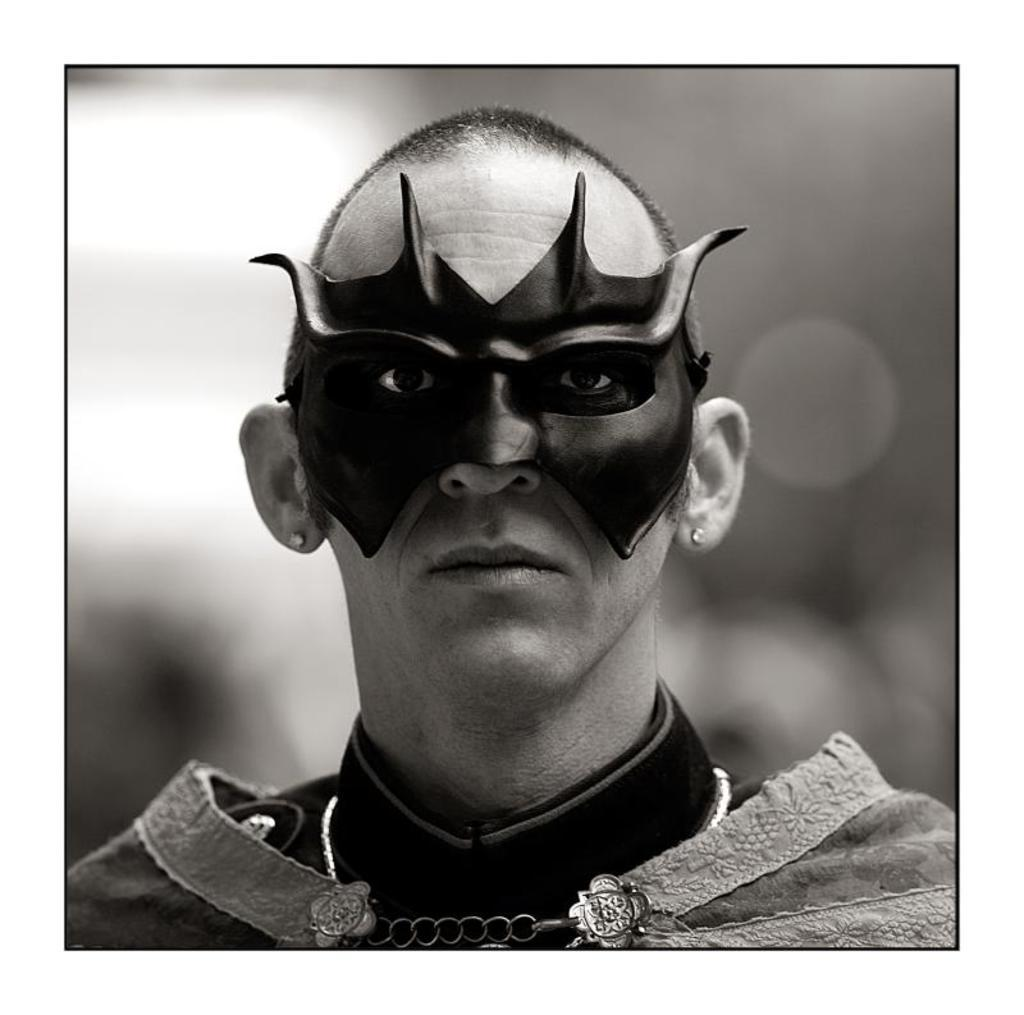What is the color scheme of the image? The image is black and white. How would you describe the background of the image? The background of the image is blurred. What is the main subject of the image? There is a man in the middle of the image. What is the man wearing in the image? The man is wearing a costume. Can you describe the man's face in the image? There is a mask on the man's face. What type of cart is being used by the man in the image? There is no cart present in the image; the man is wearing a costume and has a mask on his face. 